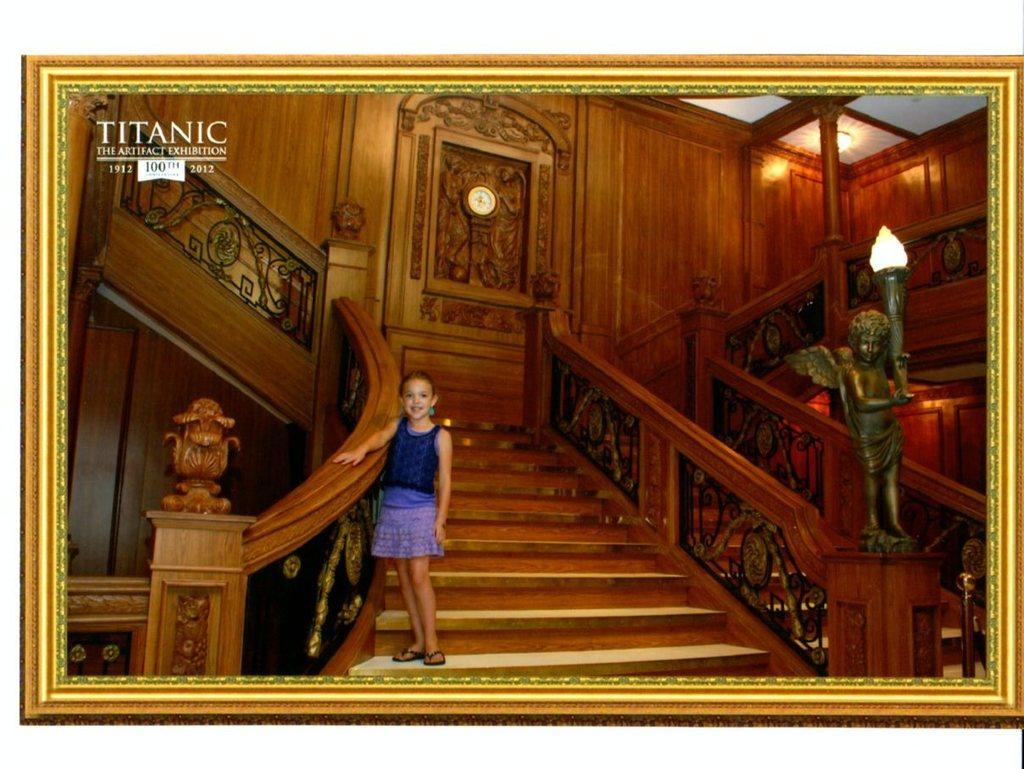What is featured on the wall hanging in the image? The wall hanging depicts a child standing on a staircase. What is the child doing in the depiction? The child is holding railings in the depiction. Are there any other elements in the wall hanging besides the child? Yes, there is a statue and a sculpture in the wall hanging. What type of lighting is present in the wall hanging? Electric lights are present in the wall hanging. How does the goose feel about the child's actions in the wall hanging? There is no goose present in the wall hanging, so it is not possible to determine how a goose might feel about the child's actions. 